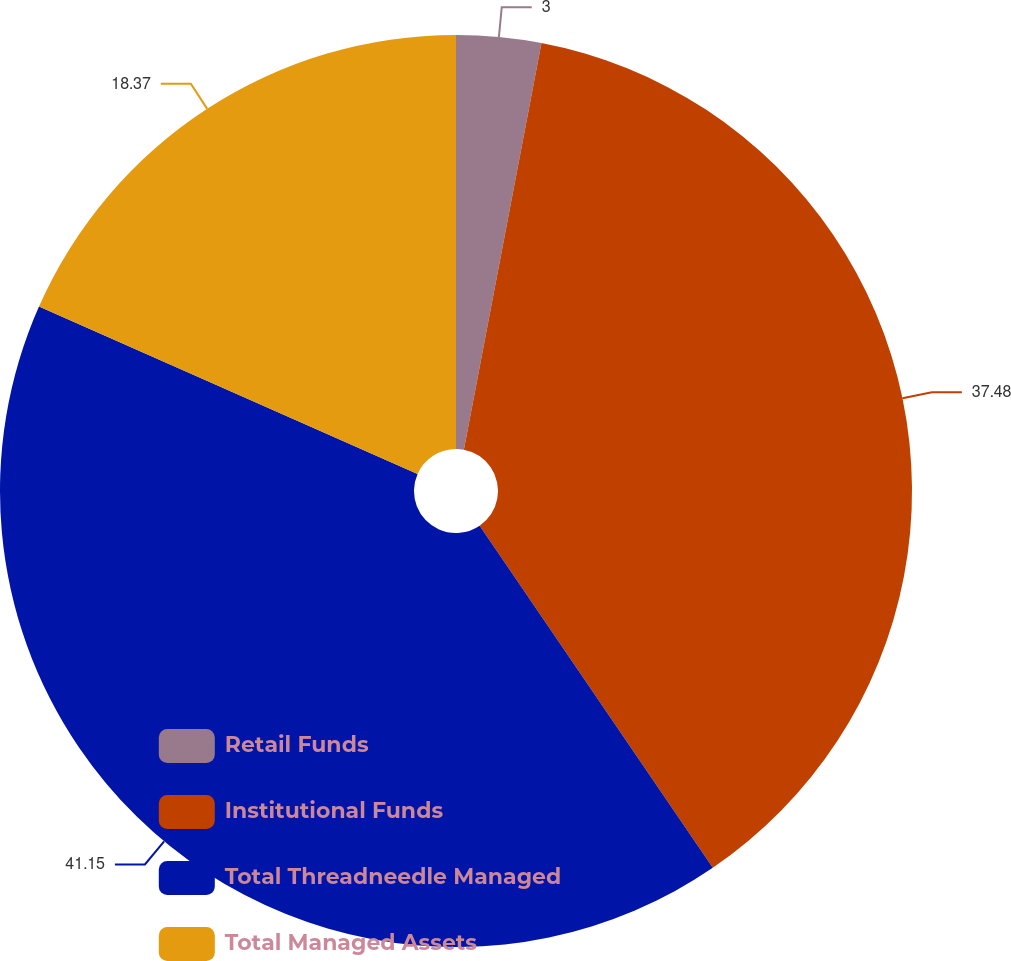Convert chart to OTSL. <chart><loc_0><loc_0><loc_500><loc_500><pie_chart><fcel>Retail Funds<fcel>Institutional Funds<fcel>Total Threadneedle Managed<fcel>Total Managed Assets<nl><fcel>3.0%<fcel>37.48%<fcel>41.15%<fcel>18.37%<nl></chart> 